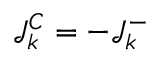Convert formula to latex. <formula><loc_0><loc_0><loc_500><loc_500>\mathcal { J } _ { k } ^ { C } = - \mathcal { J } _ { k } ^ { - }</formula> 